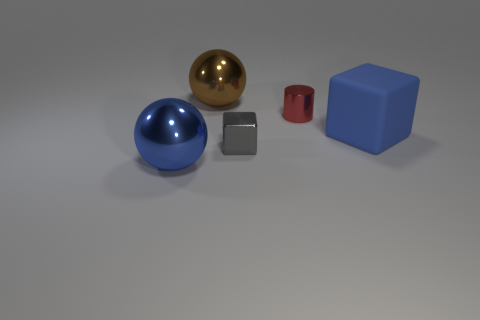Are there any other things that have the same material as the blue block?
Your answer should be compact. No. The thing that is both left of the large cube and to the right of the small gray thing has what shape?
Offer a very short reply. Cylinder. There is a cube on the left side of the blue object that is to the right of the blue shiny thing; what number of metallic cubes are behind it?
Your answer should be very brief. 0. What is the color of the object that is in front of the tiny cylinder and behind the shiny cube?
Your answer should be compact. Blue. How many other shiny blocks have the same color as the metallic block?
Ensure brevity in your answer.  0. What number of spheres are either gray things or metallic objects?
Ensure brevity in your answer.  2. There is a cylinder that is the same size as the gray shiny cube; what is its color?
Give a very brief answer. Red. There is a sphere behind the cube right of the red cylinder; is there a object to the left of it?
Offer a terse response. Yes. How big is the red cylinder?
Offer a terse response. Small. What number of things are either big yellow things or metallic balls?
Your answer should be very brief. 2. 